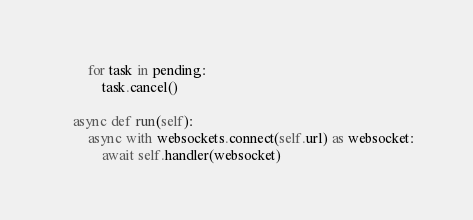<code> <loc_0><loc_0><loc_500><loc_500><_Python_>        for task in pending:
            task.cancel()

    async def run(self):
        async with websockets.connect(self.url) as websocket:
            await self.handler(websocket)
</code> 